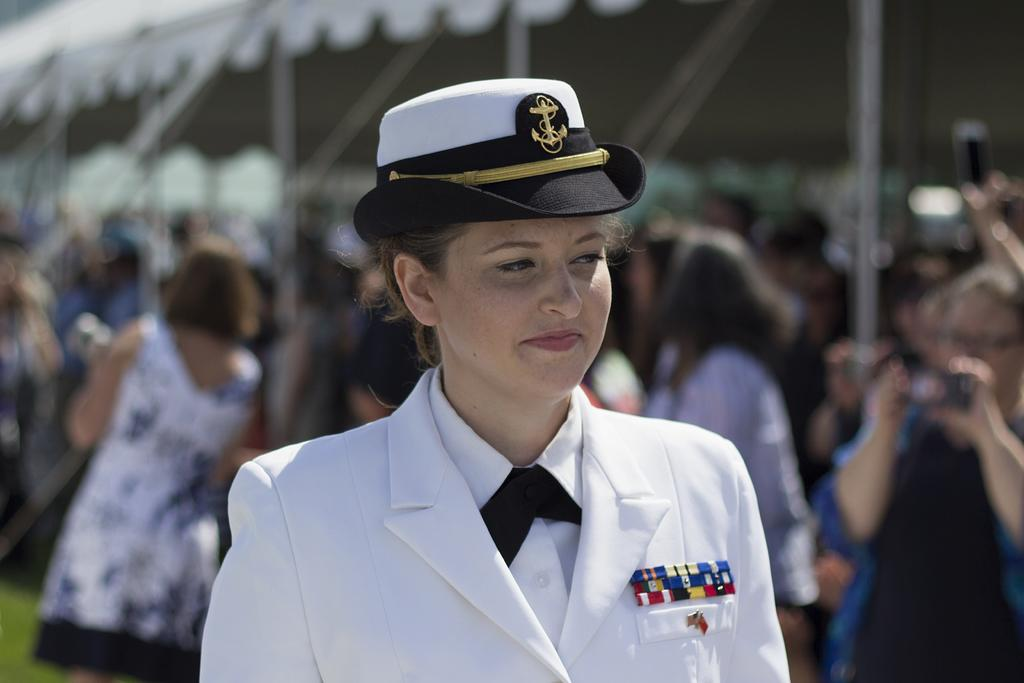Who is present in the image? There is a woman in the image. What is the woman's facial expression? The woman is smiling. What is the woman wearing on her head? The woman is wearing a cap. Can you describe the background of the image? The background of the image is blurry. What can be seen in the background of the image? There are people and grass in the background of the image. What type of pleasure appliance can be seen in the woman's hand in the image? There is no pleasure appliance visible in the woman's hand in the image. 